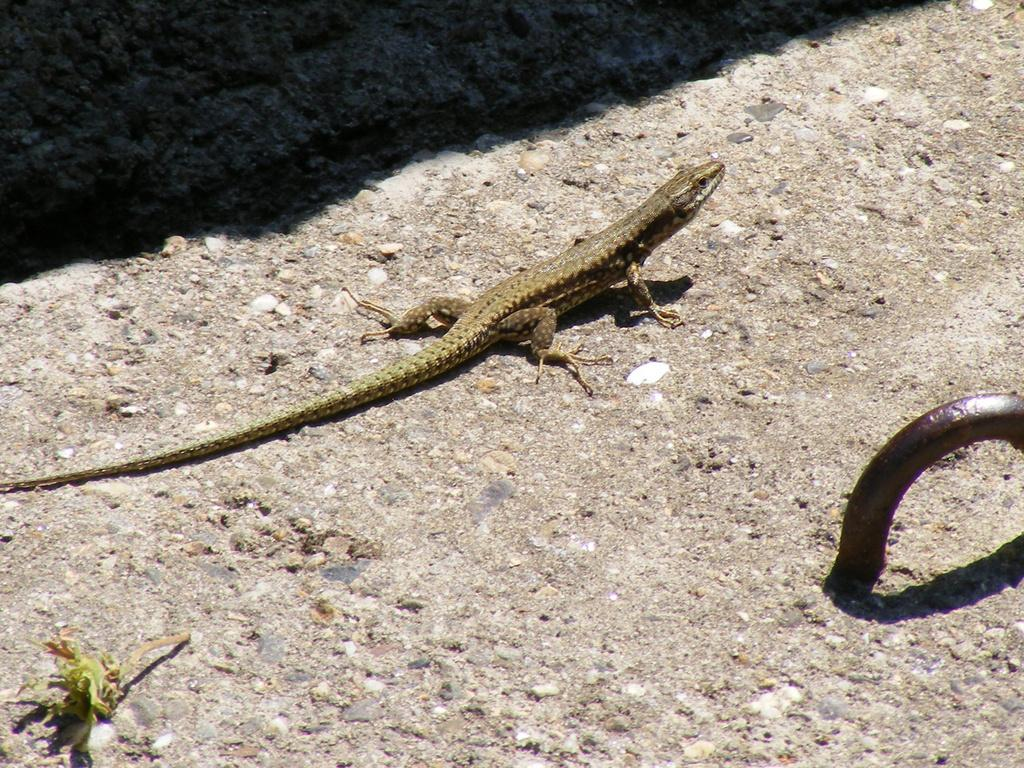What type of animal is in the picture? There is a reptile in the picture. What is the reptile resting on or in contact with? The reptile is on a surface. What other object can be seen in the picture? There is an iron metal object in the picture. What type of bubble can be seen in the picture? There is no bubble present in the picture. What type of crate is visible in the picture? There is no crate present in the picture. 